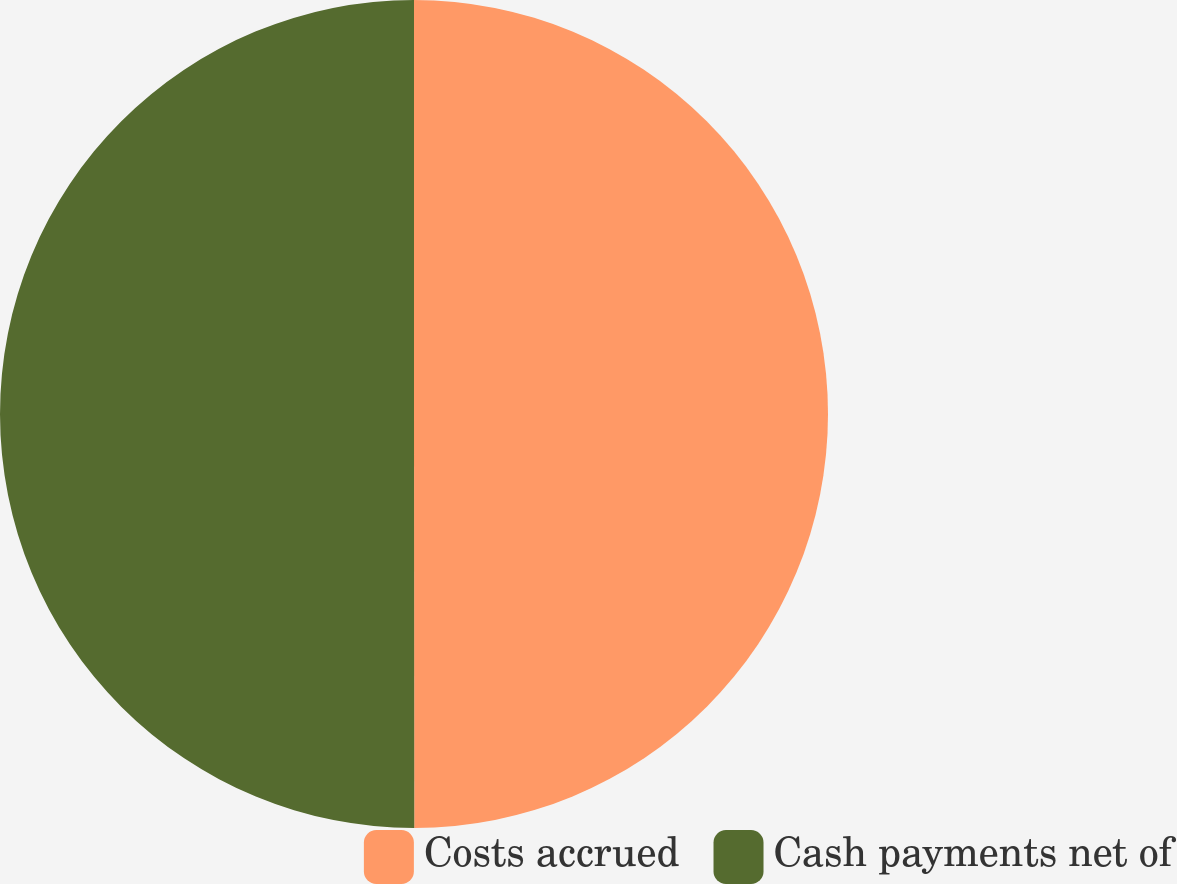Convert chart to OTSL. <chart><loc_0><loc_0><loc_500><loc_500><pie_chart><fcel>Costs accrued<fcel>Cash payments net of<nl><fcel>49.99%<fcel>50.01%<nl></chart> 